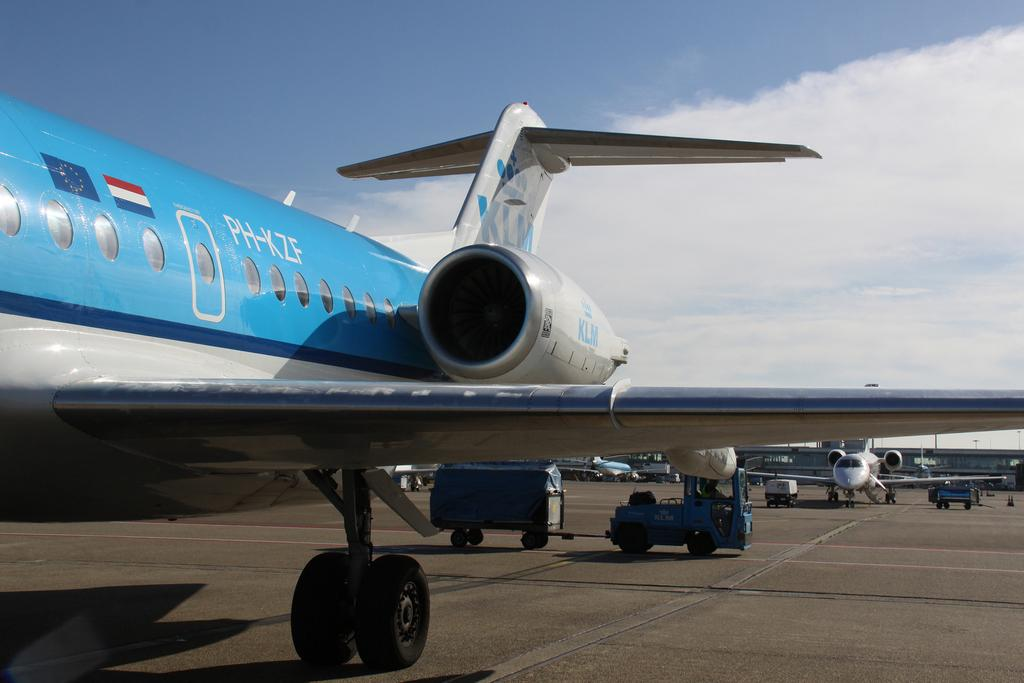Provide a one-sentence caption for the provided image. A jet plane with the letters PH-ZKF written on it. 